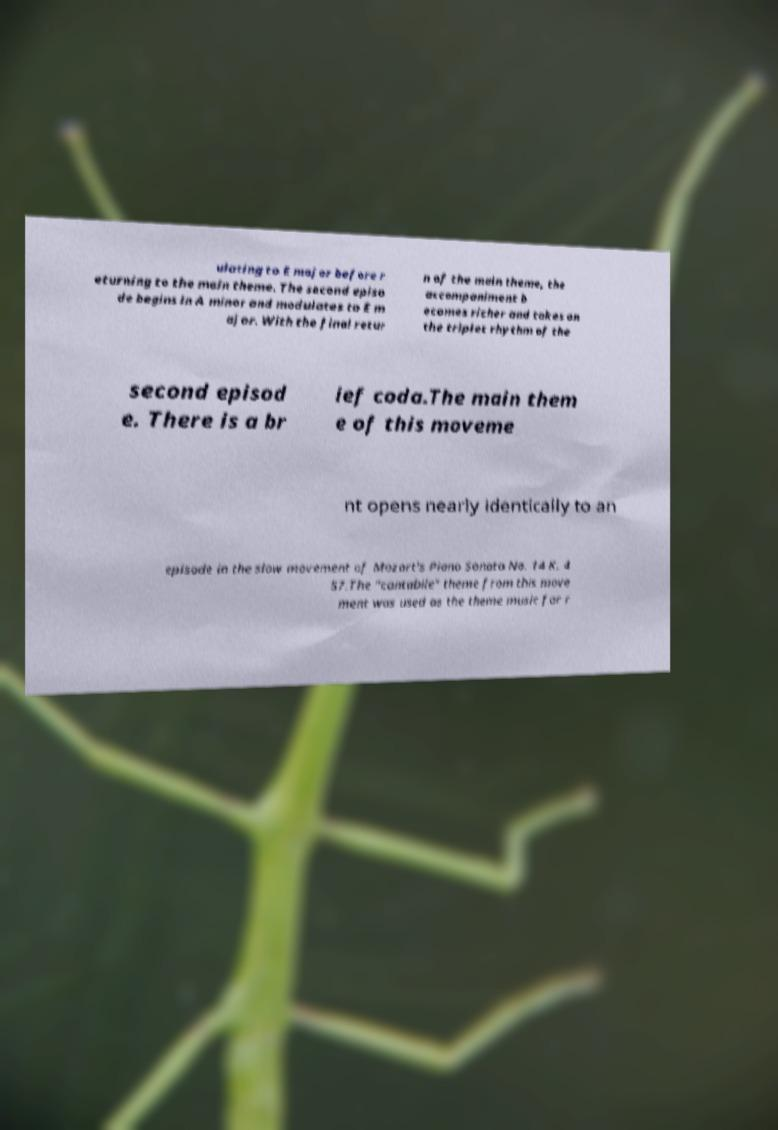Could you assist in decoding the text presented in this image and type it out clearly? ulating to E major before r eturning to the main theme. The second episo de begins in A minor and modulates to E m ajor. With the final retur n of the main theme, the accompaniment b ecomes richer and takes on the triplet rhythm of the second episod e. There is a br ief coda.The main them e of this moveme nt opens nearly identically to an episode in the slow movement of Mozart's Piano Sonata No. 14 K. 4 57.The "cantabile" theme from this move ment was used as the theme music for r 